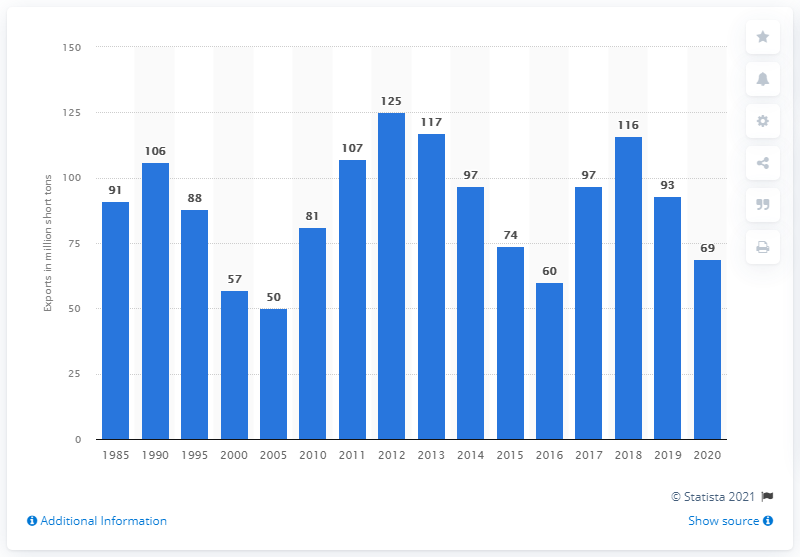Identify some key points in this picture. The United States exported 69 million short tons of bituminous coal in 2020. In the year 2000, the United States exported 57 million short tons of bituminous coal. In 2000, the United States exported 57 million short tons of bituminous coal. 